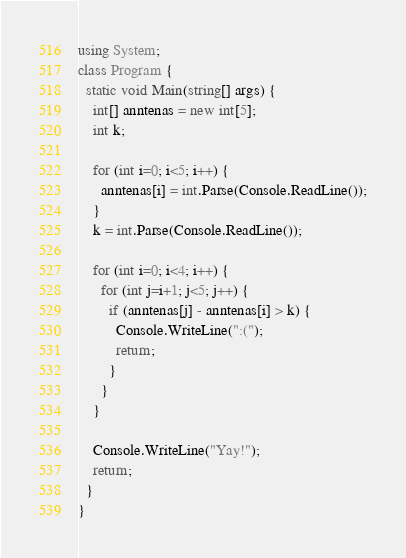<code> <loc_0><loc_0><loc_500><loc_500><_C#_>using System;
class Program { 
  static void Main(string[] args) {
    int[] anntenas = new int[5];
    int k;
    
    for (int i=0; i<5; i++) {
      anntenas[i] = int.Parse(Console.ReadLine());
    }
    k = int.Parse(Console.ReadLine());
    
    for (int i=0; i<4; i++) {
      for (int j=i+1; j<5; j++) {
        if (anntenas[j] - anntenas[i] > k) {
          Console.WriteLine(":(");
          return;
        }
      }
    }
    
    Console.WriteLine("Yay!");
    return;
  }
}</code> 